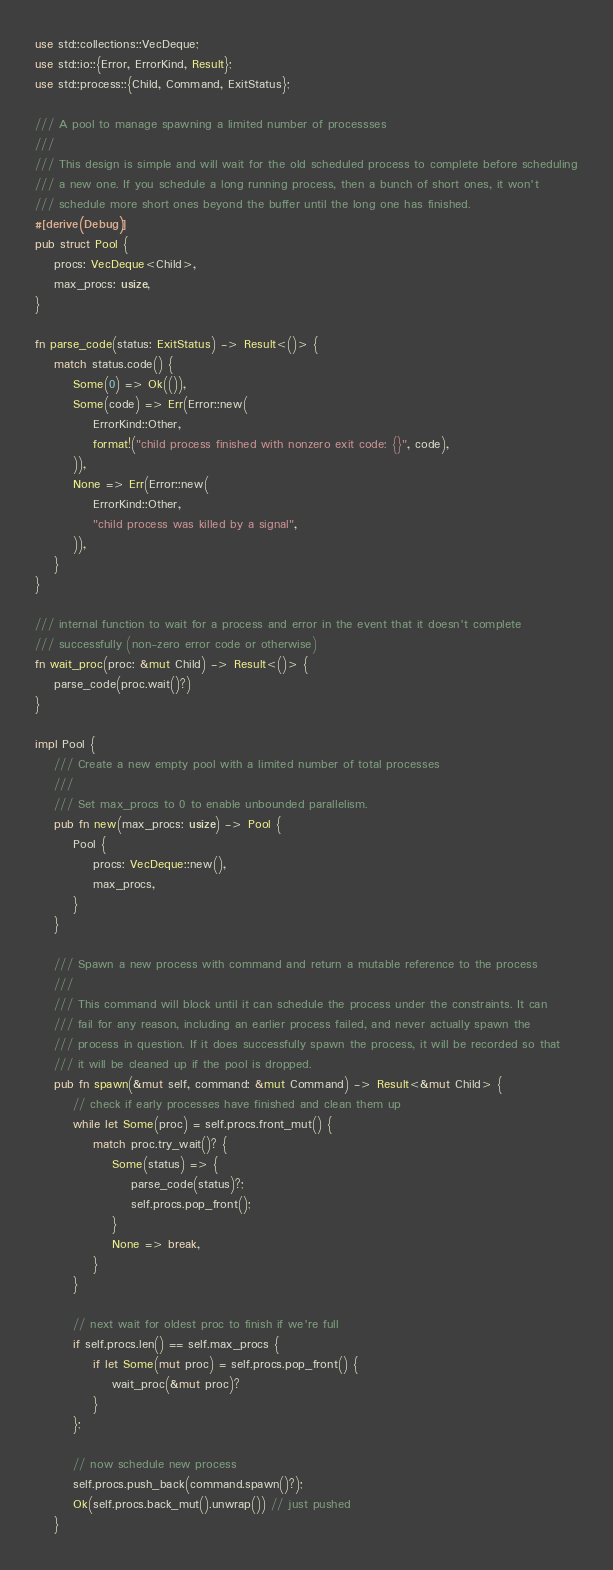Convert code to text. <code><loc_0><loc_0><loc_500><loc_500><_Rust_>use std::collections::VecDeque;
use std::io::{Error, ErrorKind, Result};
use std::process::{Child, Command, ExitStatus};

/// A pool to manage spawning a limited number of processses
///
/// This design is simple and will wait for the old scheduled process to complete before scheduling
/// a new one. If you schedule a long running process, then a bunch of short ones, it won't
/// schedule more short ones beyond the buffer until the long one has finished.
#[derive(Debug)]
pub struct Pool {
    procs: VecDeque<Child>,
    max_procs: usize,
}

fn parse_code(status: ExitStatus) -> Result<()> {
    match status.code() {
        Some(0) => Ok(()),
        Some(code) => Err(Error::new(
            ErrorKind::Other,
            format!("child process finished with nonzero exit code: {}", code),
        )),
        None => Err(Error::new(
            ErrorKind::Other,
            "child process was killed by a signal",
        )),
    }
}

/// internal function to wait for a process and error in the event that it doesn't complete
/// successfully (non-zero error code or otherwise)
fn wait_proc(proc: &mut Child) -> Result<()> {
    parse_code(proc.wait()?)
}

impl Pool {
    /// Create a new empty pool with a limited number of total processes
    ///
    /// Set max_procs to 0 to enable unbounded parallelism.
    pub fn new(max_procs: usize) -> Pool {
        Pool {
            procs: VecDeque::new(),
            max_procs,
        }
    }

    /// Spawn a new process with command and return a mutable reference to the process
    ///
    /// This command will block until it can schedule the process under the constraints. It can
    /// fail for any reason, including an earlier process failed, and never actually spawn the
    /// process in question. If it does successfully spawn the process, it will be recorded so that
    /// it will be cleaned up if the pool is dropped.
    pub fn spawn(&mut self, command: &mut Command) -> Result<&mut Child> {
        // check if early processes have finished and clean them up
        while let Some(proc) = self.procs.front_mut() {
            match proc.try_wait()? {
                Some(status) => {
                    parse_code(status)?;
                    self.procs.pop_front();
                }
                None => break,
            }
        }

        // next wait for oldest proc to finish if we're full
        if self.procs.len() == self.max_procs {
            if let Some(mut proc) = self.procs.pop_front() {
                wait_proc(&mut proc)?
            }
        };

        // now schedule new process
        self.procs.push_back(command.spawn()?);
        Ok(self.procs.back_mut().unwrap()) // just pushed
    }
</code> 